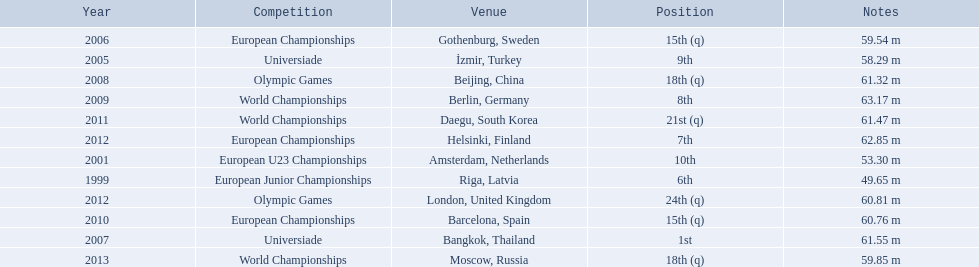What were the distances of mayer's throws? 49.65 m, 53.30 m, 58.29 m, 59.54 m, 61.55 m, 61.32 m, 63.17 m, 60.76 m, 61.47 m, 62.85 m, 60.81 m, 59.85 m. Could you help me parse every detail presented in this table? {'header': ['Year', 'Competition', 'Venue', 'Position', 'Notes'], 'rows': [['2006', 'European Championships', 'Gothenburg, Sweden', '15th (q)', '59.54 m'], ['2005', 'Universiade', 'İzmir, Turkey', '9th', '58.29 m'], ['2008', 'Olympic Games', 'Beijing, China', '18th (q)', '61.32 m'], ['2009', 'World Championships', 'Berlin, Germany', '8th', '63.17 m'], ['2011', 'World Championships', 'Daegu, South Korea', '21st (q)', '61.47 m'], ['2012', 'European Championships', 'Helsinki, Finland', '7th', '62.85 m'], ['2001', 'European U23 Championships', 'Amsterdam, Netherlands', '10th', '53.30 m'], ['1999', 'European Junior Championships', 'Riga, Latvia', '6th', '49.65 m'], ['2012', 'Olympic Games', 'London, United Kingdom', '24th (q)', '60.81 m'], ['2010', 'European Championships', 'Barcelona, Spain', '15th (q)', '60.76 m'], ['2007', 'Universiade', 'Bangkok, Thailand', '1st', '61.55 m'], ['2013', 'World Championships', 'Moscow, Russia', '18th (q)', '59.85 m']]} Which of these went the farthest? 63.17 m. 